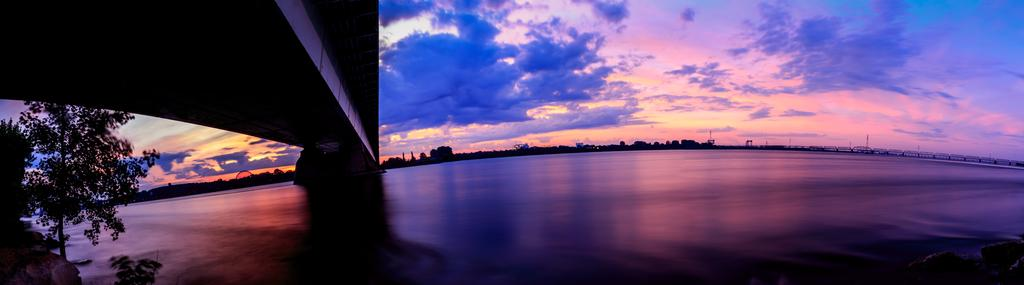What is the primary feature of the image? The primary feature of the image is a water surface. What is located above the water surface? There is a bridge above the water surface. What type of vegetation can be seen on the left side of the image? There is a tree on the left side of the image. What type of railway is visible in the image? There is no railway present in the image. What kind of hall can be seen on the right side of the image? There is no hall present in the image. 